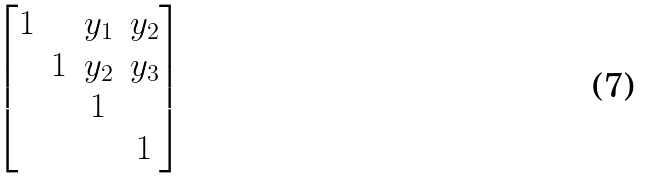Convert formula to latex. <formula><loc_0><loc_0><loc_500><loc_500>\begin{bmatrix} 1 & & y _ { 1 } & y _ { 2 } \\ & 1 & y _ { 2 } & y _ { 3 } \\ & & 1 & \\ & & & 1 \end{bmatrix}</formula> 